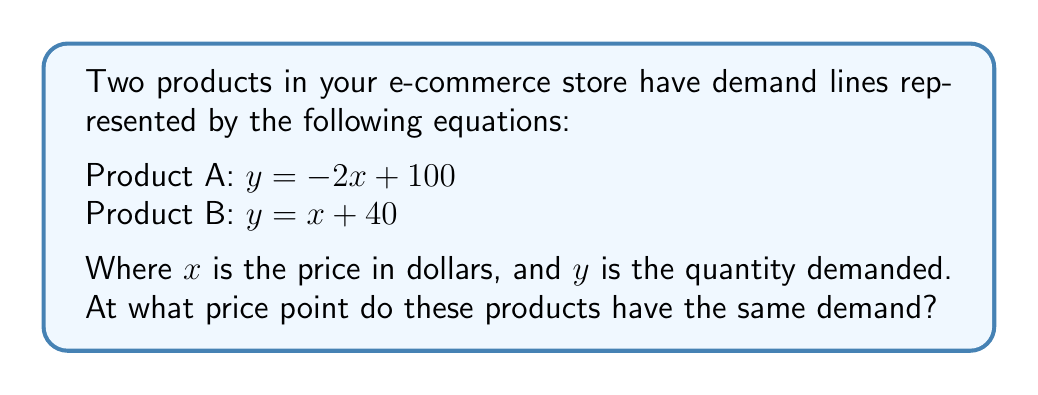Provide a solution to this math problem. To find the intersection point of these two demand lines, we need to solve the system of equations:

1) Set the equations equal to each other:
   $-2x + 100 = x + 40$

2) Solve for x:
   $-2x + 100 = x + 40$
   $-3x = -60$
   $x = 20$

3) Substitute $x = 20$ into either equation to find $y$:
   Using Product A's equation: $y = -2(20) + 100 = -40 + 100 = 60$

4) Therefore, the intersection point is (20, 60).

This means that when both products are priced at $20, the demand for each product is 60 units.
Answer: (20, 60) 